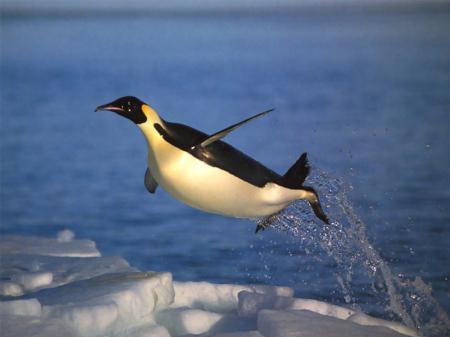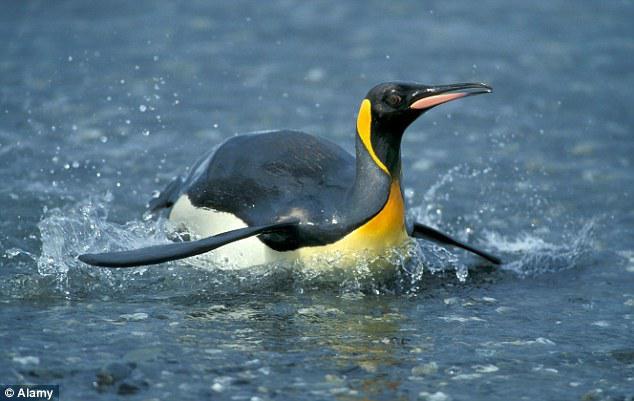The first image is the image on the left, the second image is the image on the right. Evaluate the accuracy of this statement regarding the images: "There are two penguins in the image pair.". Is it true? Answer yes or no. Yes. 